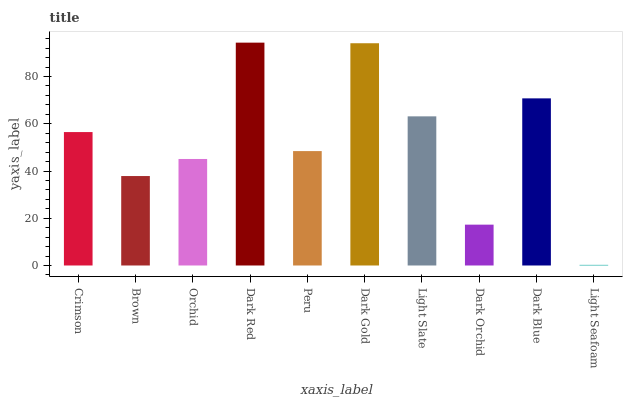Is Light Seafoam the minimum?
Answer yes or no. Yes. Is Dark Red the maximum?
Answer yes or no. Yes. Is Brown the minimum?
Answer yes or no. No. Is Brown the maximum?
Answer yes or no. No. Is Crimson greater than Brown?
Answer yes or no. Yes. Is Brown less than Crimson?
Answer yes or no. Yes. Is Brown greater than Crimson?
Answer yes or no. No. Is Crimson less than Brown?
Answer yes or no. No. Is Crimson the high median?
Answer yes or no. Yes. Is Peru the low median?
Answer yes or no. Yes. Is Dark Gold the high median?
Answer yes or no. No. Is Dark Orchid the low median?
Answer yes or no. No. 